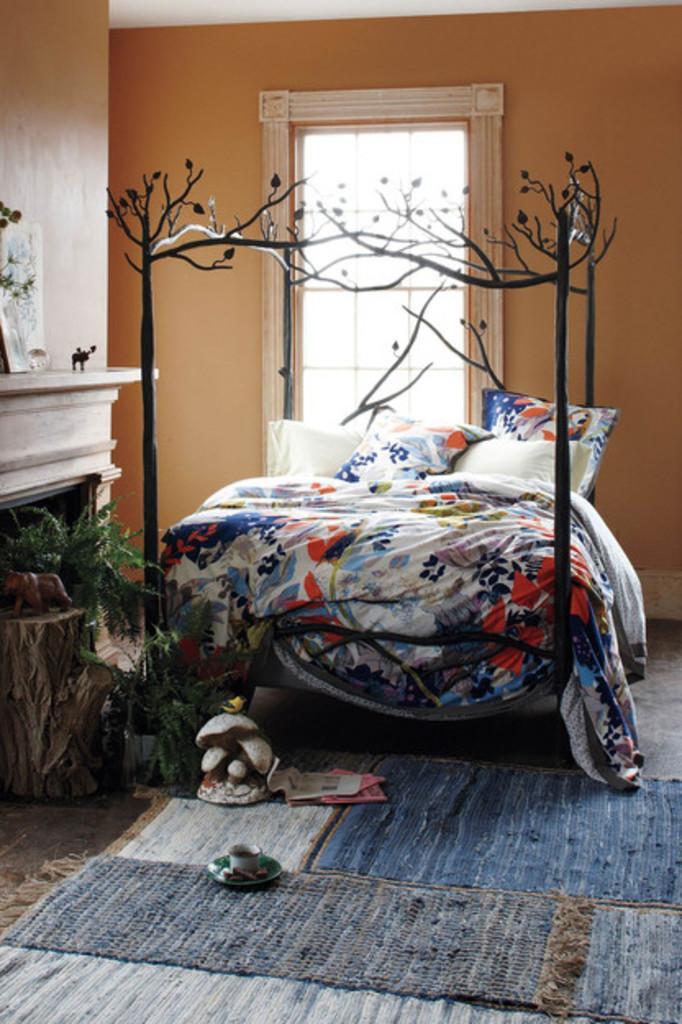Could you give a brief overview of what you see in this image? In this image I can see few floor mats on the ground and on the floor mats I can see a saucer, a cup and few other objects. In the background I can see a artificial wooden log, few artificial plants, a bed on which I can see few pillows which are white, blue and orange in color, a window, a orange colored wall, a fire place and few objects on the fireplace. 